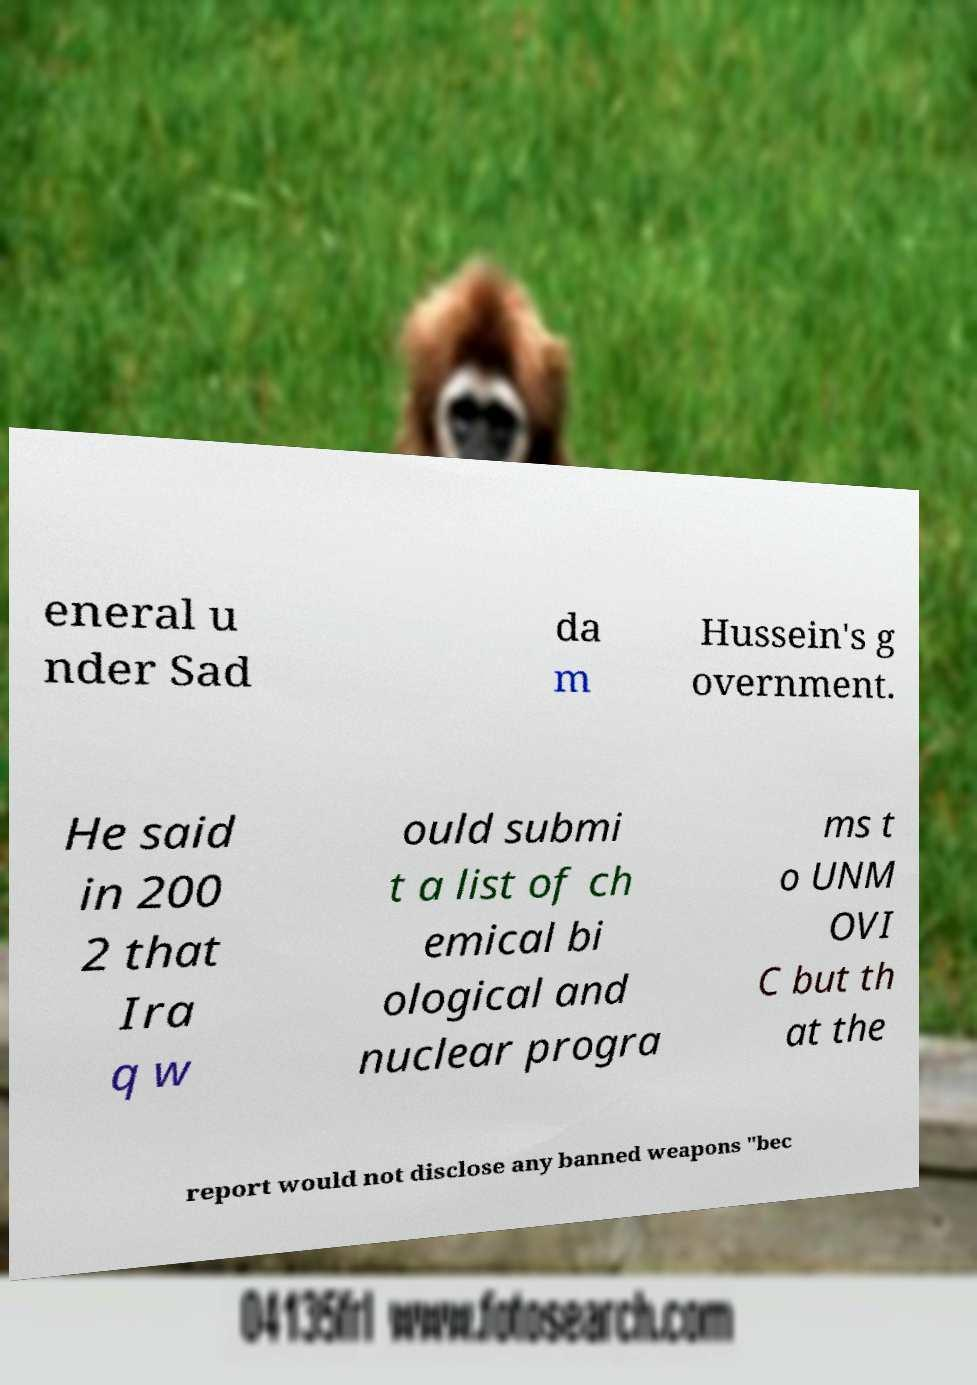Please read and relay the text visible in this image. What does it say? eneral u nder Sad da m Hussein's g overnment. He said in 200 2 that Ira q w ould submi t a list of ch emical bi ological and nuclear progra ms t o UNM OVI C but th at the report would not disclose any banned weapons "bec 